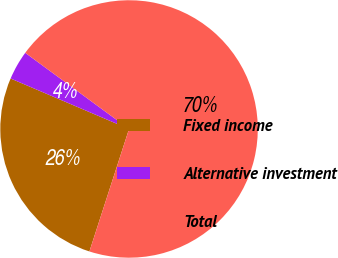<chart> <loc_0><loc_0><loc_500><loc_500><pie_chart><fcel>Fixed income<fcel>Alternative investment<fcel>Total<nl><fcel>26.43%<fcel>3.66%<fcel>69.9%<nl></chart> 